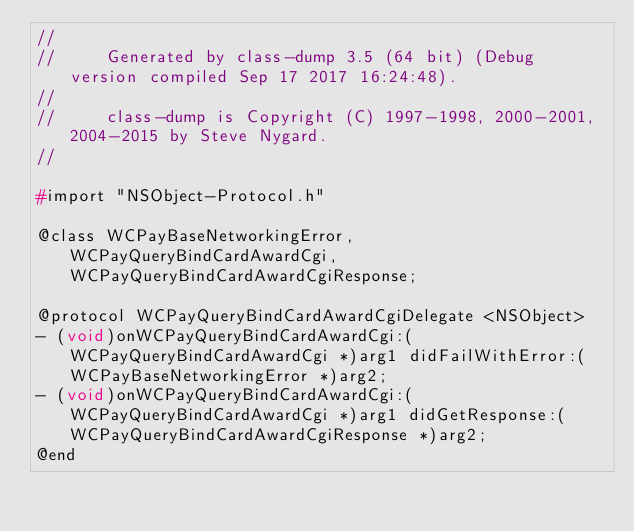<code> <loc_0><loc_0><loc_500><loc_500><_C_>//
//     Generated by class-dump 3.5 (64 bit) (Debug version compiled Sep 17 2017 16:24:48).
//
//     class-dump is Copyright (C) 1997-1998, 2000-2001, 2004-2015 by Steve Nygard.
//

#import "NSObject-Protocol.h"

@class WCPayBaseNetworkingError, WCPayQueryBindCardAwardCgi, WCPayQueryBindCardAwardCgiResponse;

@protocol WCPayQueryBindCardAwardCgiDelegate <NSObject>
- (void)onWCPayQueryBindCardAwardCgi:(WCPayQueryBindCardAwardCgi *)arg1 didFailWithError:(WCPayBaseNetworkingError *)arg2;
- (void)onWCPayQueryBindCardAwardCgi:(WCPayQueryBindCardAwardCgi *)arg1 didGetResponse:(WCPayQueryBindCardAwardCgiResponse *)arg2;
@end

</code> 